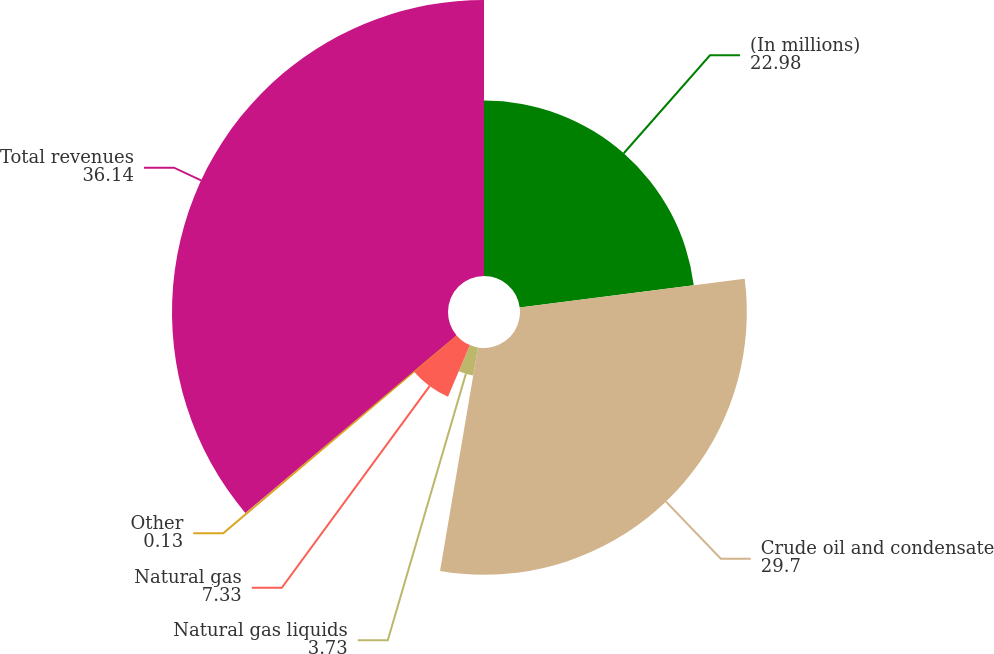Convert chart. <chart><loc_0><loc_0><loc_500><loc_500><pie_chart><fcel>(In millions)<fcel>Crude oil and condensate<fcel>Natural gas liquids<fcel>Natural gas<fcel>Other<fcel>Total revenues<nl><fcel>22.98%<fcel>29.7%<fcel>3.73%<fcel>7.33%<fcel>0.13%<fcel>36.14%<nl></chart> 